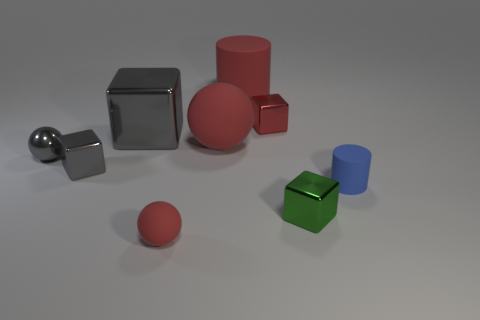What size is the red cube that is made of the same material as the green block?
Keep it short and to the point. Small. There is a red block that is on the right side of the red matte cylinder; is its size the same as the metallic block in front of the tiny blue cylinder?
Ensure brevity in your answer.  Yes. What material is the gray ball that is the same size as the red shiny object?
Your response must be concise. Metal. The small thing that is to the left of the large red matte cylinder and in front of the blue matte cylinder is made of what material?
Ensure brevity in your answer.  Rubber. Is there a small gray rubber object?
Offer a terse response. No. Does the tiny rubber ball have the same color as the rubber cylinder that is on the left side of the small blue rubber thing?
Your answer should be compact. Yes. There is a big thing that is the same color as the small metallic ball; what is its material?
Provide a succinct answer. Metal. Are there any other things that are the same shape as the small red metal thing?
Provide a short and direct response. Yes. There is a gray thing that is behind the tiny sphere that is to the left of the matte sphere in front of the tiny green cube; what shape is it?
Ensure brevity in your answer.  Cube. The large gray metal thing is what shape?
Make the answer very short. Cube. 